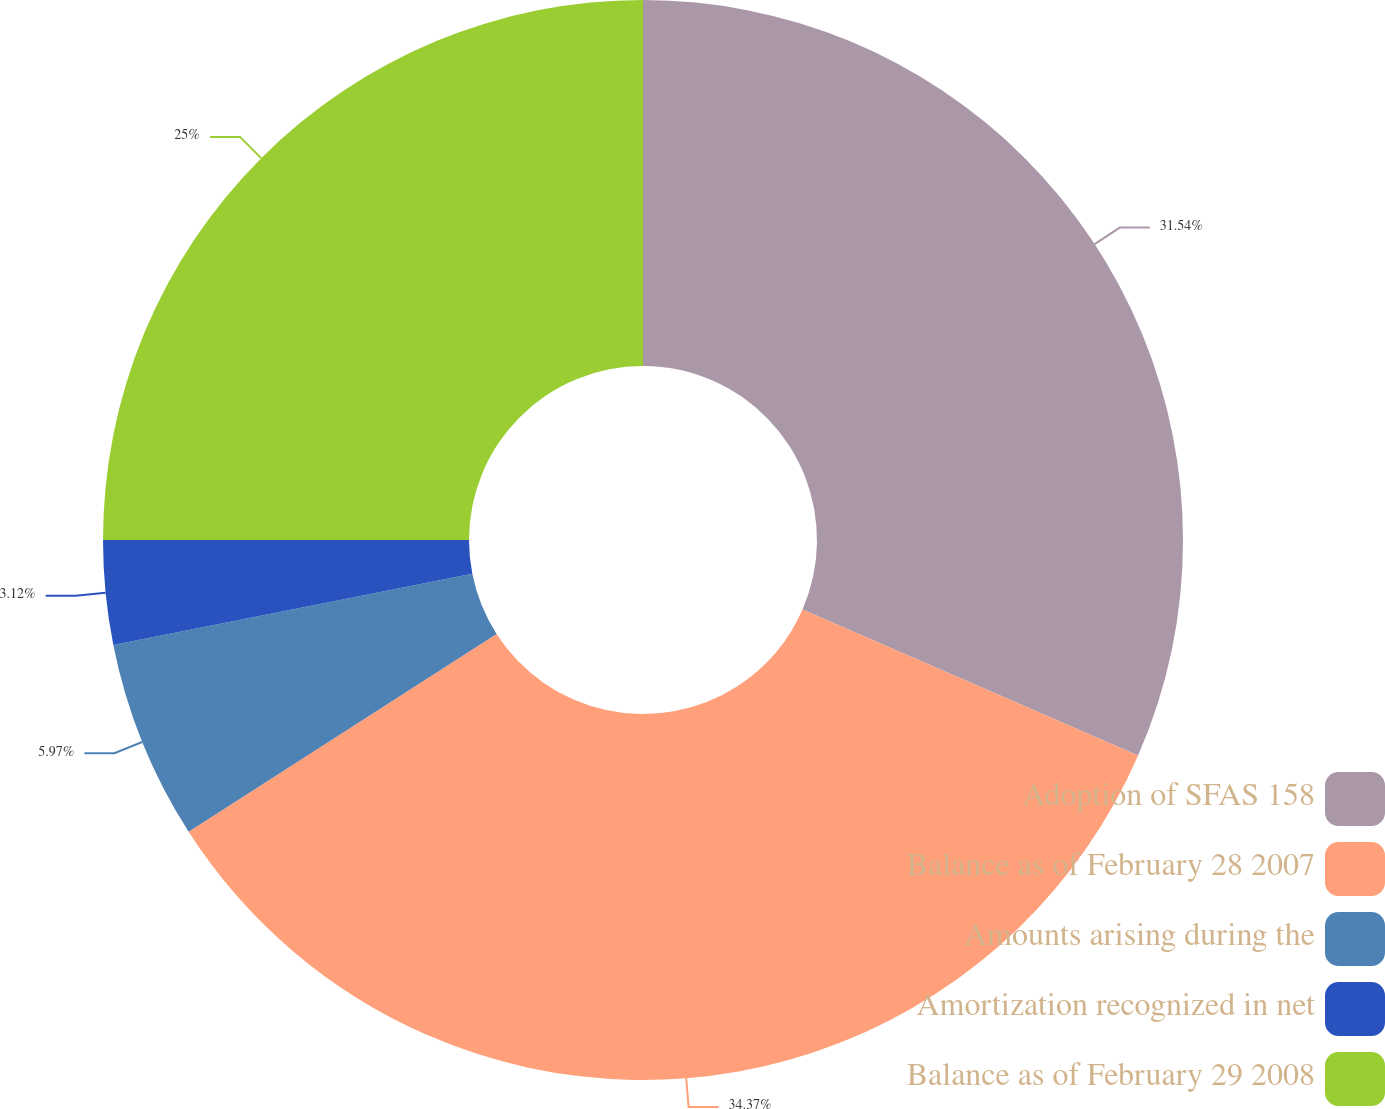Convert chart to OTSL. <chart><loc_0><loc_0><loc_500><loc_500><pie_chart><fcel>Adoption of SFAS 158<fcel>Balance as of February 28 2007<fcel>Amounts arising during the<fcel>Amortization recognized in net<fcel>Balance as of February 29 2008<nl><fcel>31.54%<fcel>34.38%<fcel>5.97%<fcel>3.12%<fcel>25.0%<nl></chart> 